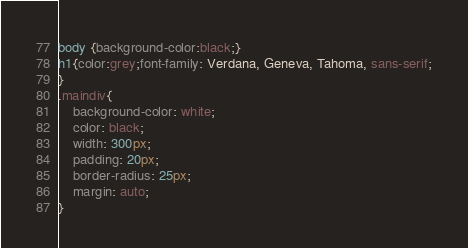Convert code to text. <code><loc_0><loc_0><loc_500><loc_500><_CSS_>body {background-color:black;}
h1{color:grey;font-family: Verdana, Geneva, Tahoma, sans-serif;
}
.maindiv{
    background-color: white;
    color: black;
    width: 300px;
    padding: 20px;
    border-radius: 25px;
    margin: auto;
}

</code> 